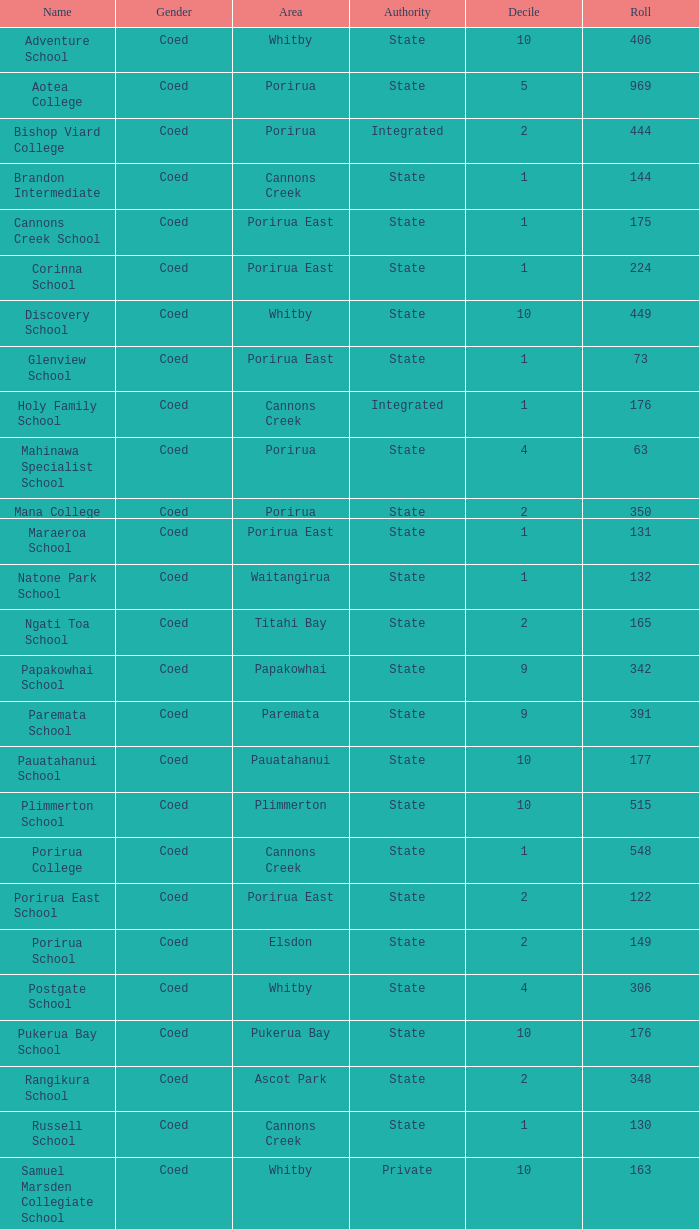What was the decile of Samuel Marsden Collegiate School in Whitby, when it had a roll higher than 163? 0.0. 